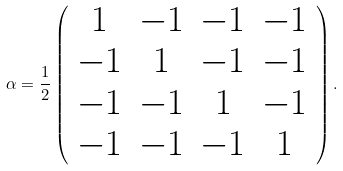Convert formula to latex. <formula><loc_0><loc_0><loc_500><loc_500>\alpha = \frac { 1 } { 2 } \left ( \begin{array} { c c c c } 1 & - 1 & - 1 & - 1 \\ - 1 & 1 & - 1 & - 1 \\ - 1 & - 1 & 1 & - 1 \\ - 1 & - 1 & - 1 & 1 \end{array} \right ) .</formula> 